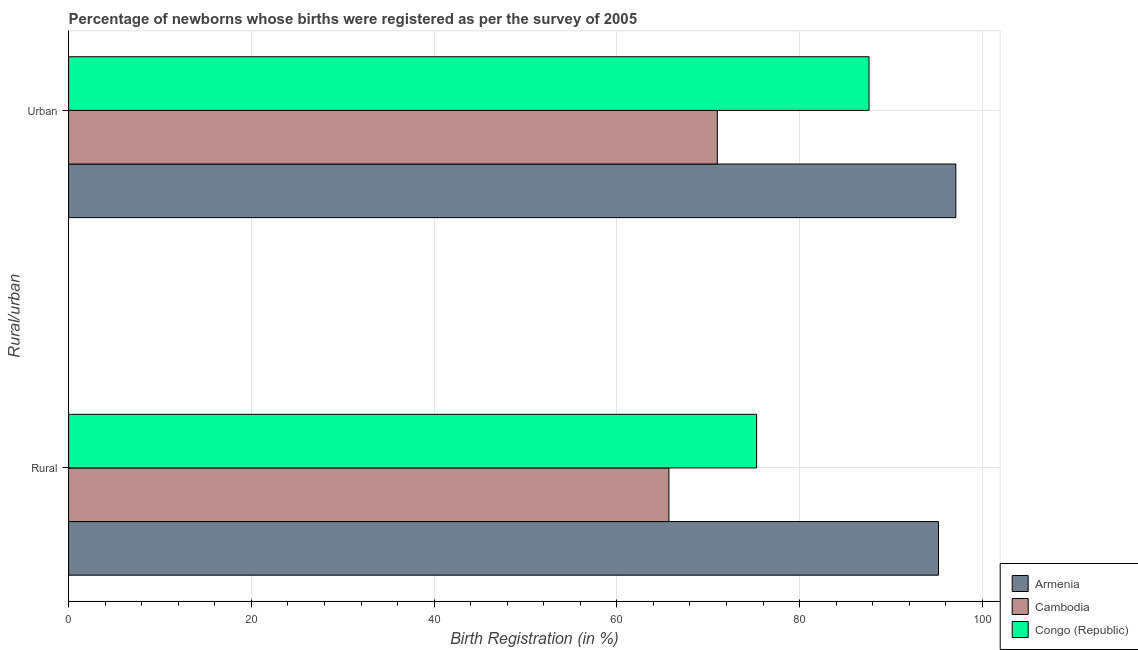How many groups of bars are there?
Provide a short and direct response. 2. Are the number of bars per tick equal to the number of legend labels?
Offer a very short reply. Yes. Are the number of bars on each tick of the Y-axis equal?
Keep it short and to the point. Yes. How many bars are there on the 2nd tick from the top?
Offer a very short reply. 3. How many bars are there on the 1st tick from the bottom?
Keep it short and to the point. 3. What is the label of the 2nd group of bars from the top?
Provide a short and direct response. Rural. Across all countries, what is the maximum rural birth registration?
Make the answer very short. 95.2. Across all countries, what is the minimum urban birth registration?
Keep it short and to the point. 71. In which country was the rural birth registration maximum?
Offer a terse response. Armenia. In which country was the rural birth registration minimum?
Keep it short and to the point. Cambodia. What is the total urban birth registration in the graph?
Offer a terse response. 255.7. What is the difference between the urban birth registration in Congo (Republic) and that in Armenia?
Your answer should be very brief. -9.5. What is the difference between the urban birth registration in Congo (Republic) and the rural birth registration in Armenia?
Ensure brevity in your answer.  -7.6. What is the average rural birth registration per country?
Your response must be concise. 78.73. What is the difference between the urban birth registration and rural birth registration in Congo (Republic)?
Provide a succinct answer. 12.3. What is the ratio of the urban birth registration in Congo (Republic) to that in Cambodia?
Your answer should be compact. 1.23. Is the rural birth registration in Congo (Republic) less than that in Cambodia?
Your answer should be compact. No. What does the 2nd bar from the top in Urban represents?
Offer a terse response. Cambodia. What does the 1st bar from the bottom in Urban represents?
Ensure brevity in your answer.  Armenia. Are all the bars in the graph horizontal?
Ensure brevity in your answer.  Yes. How many countries are there in the graph?
Offer a terse response. 3. What is the difference between two consecutive major ticks on the X-axis?
Provide a succinct answer. 20. Does the graph contain grids?
Your response must be concise. Yes. How are the legend labels stacked?
Your answer should be very brief. Vertical. What is the title of the graph?
Offer a very short reply. Percentage of newborns whose births were registered as per the survey of 2005. What is the label or title of the X-axis?
Offer a very short reply. Birth Registration (in %). What is the label or title of the Y-axis?
Provide a succinct answer. Rural/urban. What is the Birth Registration (in %) of Armenia in Rural?
Offer a very short reply. 95.2. What is the Birth Registration (in %) in Cambodia in Rural?
Ensure brevity in your answer.  65.7. What is the Birth Registration (in %) in Congo (Republic) in Rural?
Provide a short and direct response. 75.3. What is the Birth Registration (in %) of Armenia in Urban?
Keep it short and to the point. 97.1. What is the Birth Registration (in %) of Cambodia in Urban?
Provide a succinct answer. 71. What is the Birth Registration (in %) in Congo (Republic) in Urban?
Offer a terse response. 87.6. Across all Rural/urban, what is the maximum Birth Registration (in %) in Armenia?
Offer a terse response. 97.1. Across all Rural/urban, what is the maximum Birth Registration (in %) in Congo (Republic)?
Make the answer very short. 87.6. Across all Rural/urban, what is the minimum Birth Registration (in %) in Armenia?
Your answer should be compact. 95.2. Across all Rural/urban, what is the minimum Birth Registration (in %) of Cambodia?
Provide a short and direct response. 65.7. Across all Rural/urban, what is the minimum Birth Registration (in %) of Congo (Republic)?
Your answer should be compact. 75.3. What is the total Birth Registration (in %) of Armenia in the graph?
Your answer should be compact. 192.3. What is the total Birth Registration (in %) of Cambodia in the graph?
Your response must be concise. 136.7. What is the total Birth Registration (in %) in Congo (Republic) in the graph?
Keep it short and to the point. 162.9. What is the difference between the Birth Registration (in %) in Armenia in Rural and the Birth Registration (in %) in Cambodia in Urban?
Provide a succinct answer. 24.2. What is the difference between the Birth Registration (in %) in Armenia in Rural and the Birth Registration (in %) in Congo (Republic) in Urban?
Provide a short and direct response. 7.6. What is the difference between the Birth Registration (in %) of Cambodia in Rural and the Birth Registration (in %) of Congo (Republic) in Urban?
Your answer should be very brief. -21.9. What is the average Birth Registration (in %) of Armenia per Rural/urban?
Your response must be concise. 96.15. What is the average Birth Registration (in %) of Cambodia per Rural/urban?
Provide a short and direct response. 68.35. What is the average Birth Registration (in %) of Congo (Republic) per Rural/urban?
Make the answer very short. 81.45. What is the difference between the Birth Registration (in %) in Armenia and Birth Registration (in %) in Cambodia in Rural?
Your answer should be very brief. 29.5. What is the difference between the Birth Registration (in %) of Armenia and Birth Registration (in %) of Cambodia in Urban?
Your answer should be compact. 26.1. What is the difference between the Birth Registration (in %) of Armenia and Birth Registration (in %) of Congo (Republic) in Urban?
Offer a very short reply. 9.5. What is the difference between the Birth Registration (in %) in Cambodia and Birth Registration (in %) in Congo (Republic) in Urban?
Give a very brief answer. -16.6. What is the ratio of the Birth Registration (in %) in Armenia in Rural to that in Urban?
Ensure brevity in your answer.  0.98. What is the ratio of the Birth Registration (in %) of Cambodia in Rural to that in Urban?
Make the answer very short. 0.93. What is the ratio of the Birth Registration (in %) of Congo (Republic) in Rural to that in Urban?
Provide a succinct answer. 0.86. What is the difference between the highest and the second highest Birth Registration (in %) of Cambodia?
Offer a terse response. 5.3. What is the difference between the highest and the second highest Birth Registration (in %) in Congo (Republic)?
Provide a succinct answer. 12.3. What is the difference between the highest and the lowest Birth Registration (in %) of Cambodia?
Offer a very short reply. 5.3. What is the difference between the highest and the lowest Birth Registration (in %) of Congo (Republic)?
Keep it short and to the point. 12.3. 